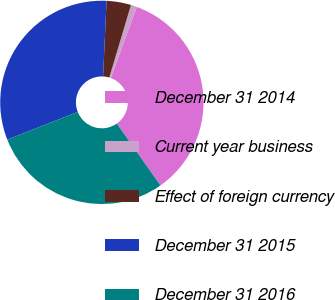Convert chart to OTSL. <chart><loc_0><loc_0><loc_500><loc_500><pie_chart><fcel>December 31 2014<fcel>Current year business<fcel>Effect of foreign currency<fcel>December 31 2015<fcel>December 31 2016<nl><fcel>34.64%<fcel>0.96%<fcel>3.88%<fcel>31.72%<fcel>28.8%<nl></chart> 